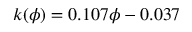<formula> <loc_0><loc_0><loc_500><loc_500>k ( \phi ) = 0 . 1 0 7 \phi - 0 . 0 3 7</formula> 